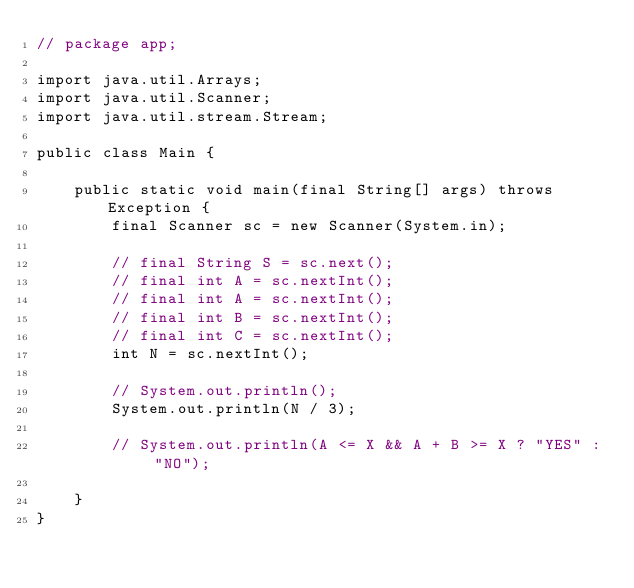<code> <loc_0><loc_0><loc_500><loc_500><_Java_>// package app;

import java.util.Arrays;
import java.util.Scanner;
import java.util.stream.Stream;

public class Main {

    public static void main(final String[] args) throws Exception {
        final Scanner sc = new Scanner(System.in);

        // final String S = sc.next();
        // final int A = sc.nextInt();
        // final int A = sc.nextInt();
        // final int B = sc.nextInt();
        // final int C = sc.nextInt();
        int N = sc.nextInt();

        // System.out.println();
        System.out.println(N / 3);

        // System.out.println(A <= X && A + B >= X ? "YES" : "NO");

    }
}</code> 